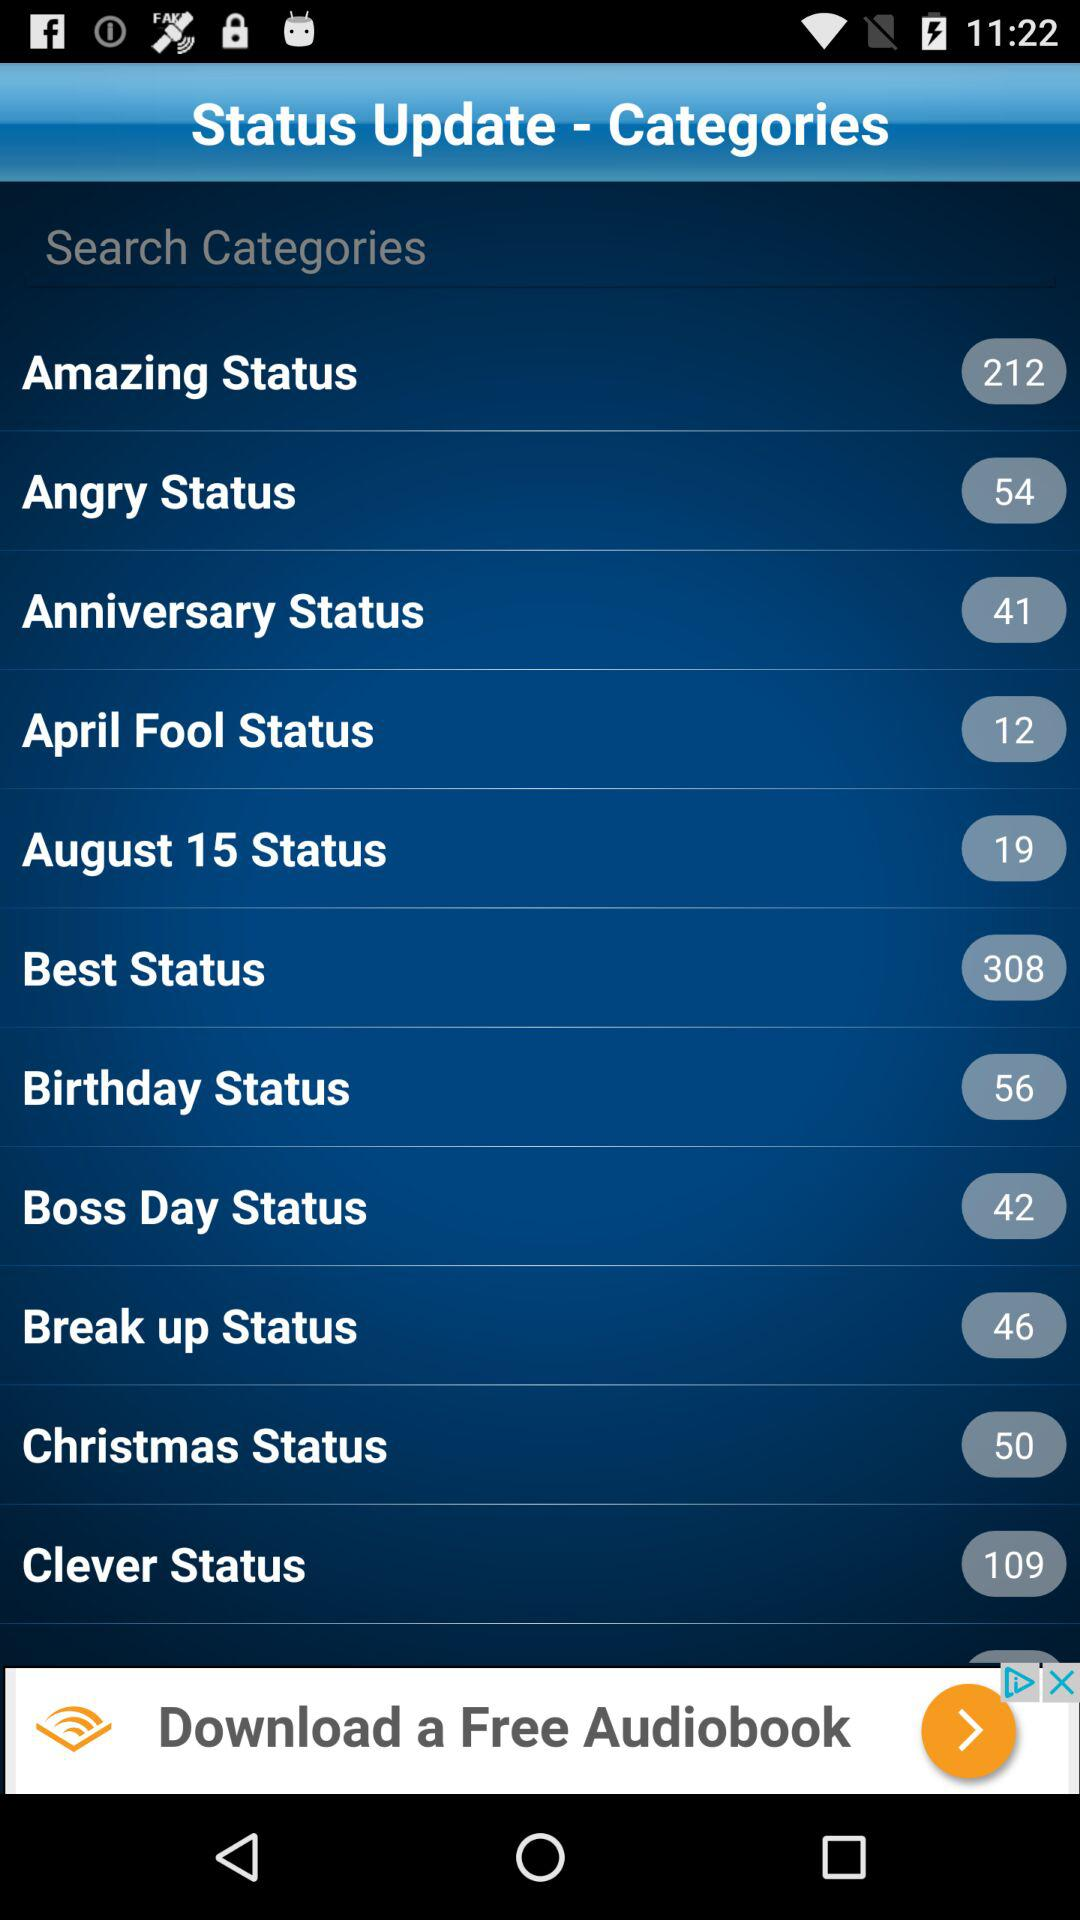What is the number of "Amazing Status"? The number of "Amazing Status" is 212. 